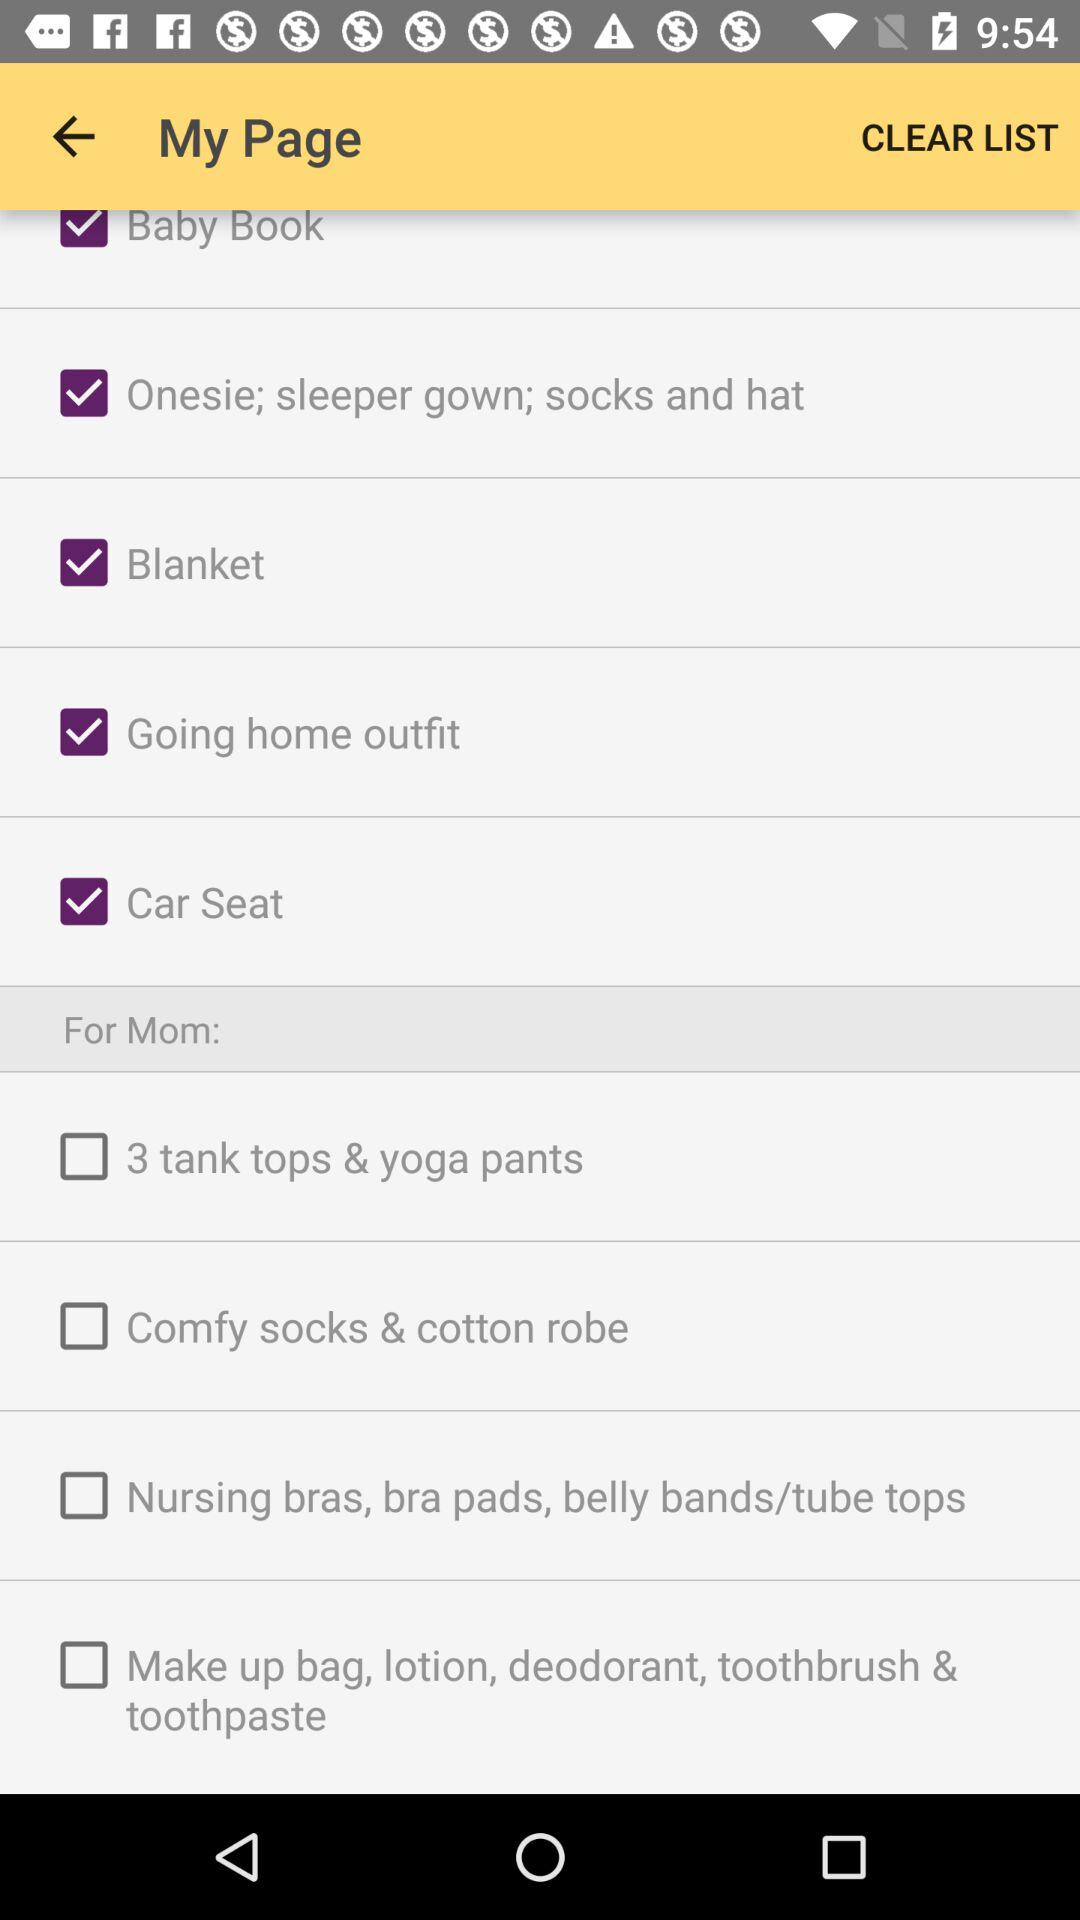What is the status of "Baby Book"? The status of "Baby Book" is "on". 